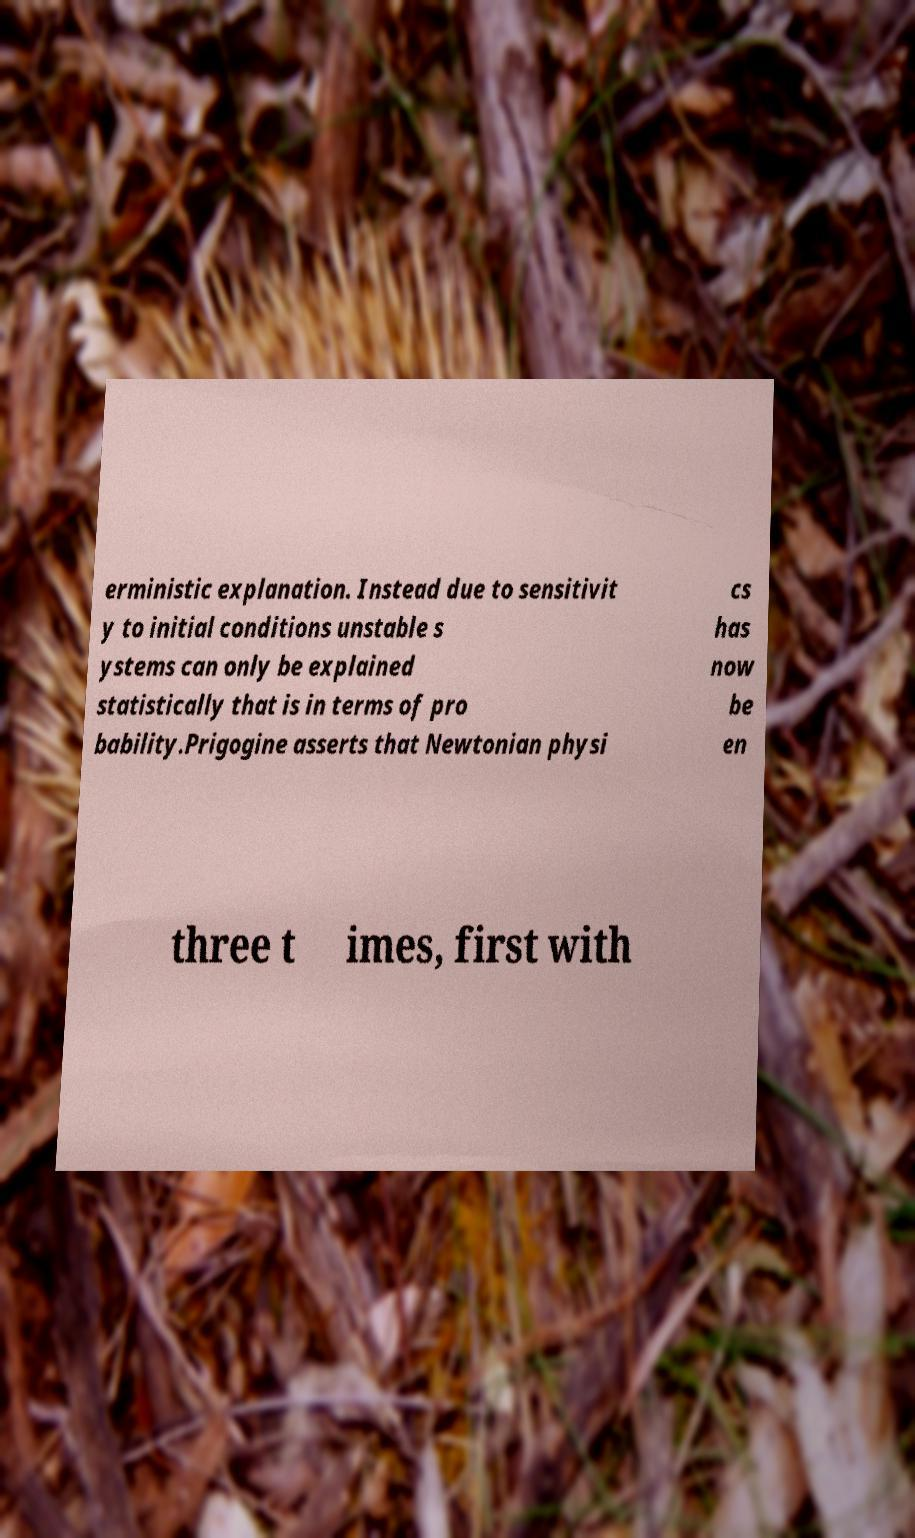For documentation purposes, I need the text within this image transcribed. Could you provide that? erministic explanation. Instead due to sensitivit y to initial conditions unstable s ystems can only be explained statistically that is in terms of pro bability.Prigogine asserts that Newtonian physi cs has now be en three t imes, first with 